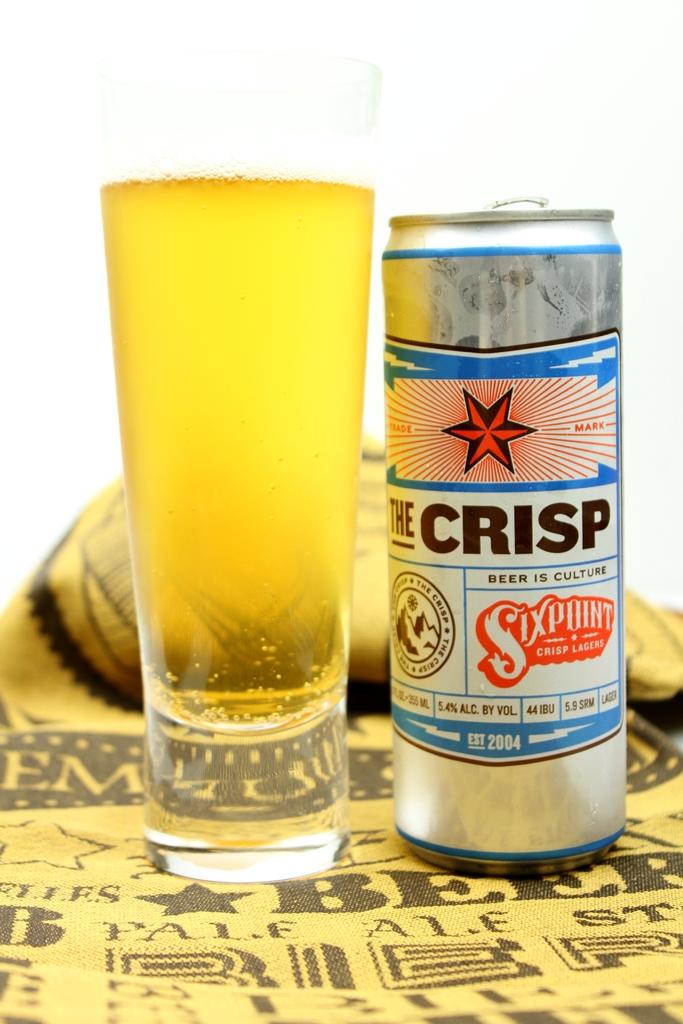When was the brand established?
Your answer should be very brief. 2004. 